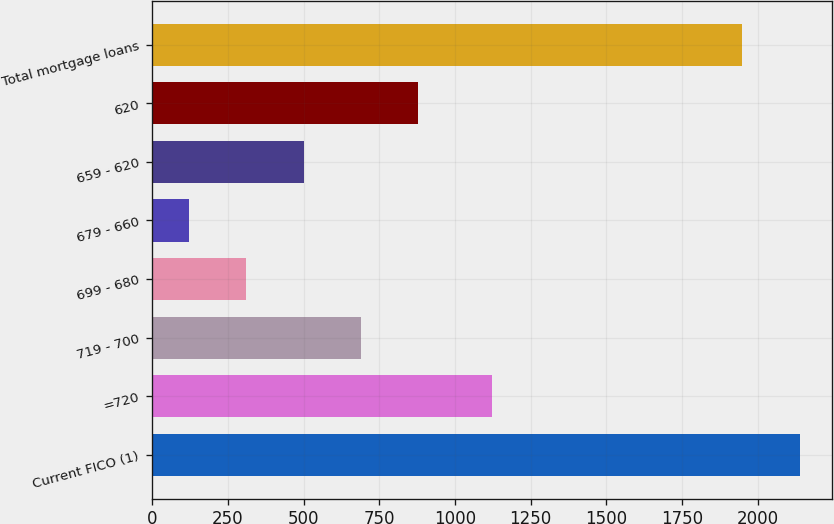Convert chart. <chart><loc_0><loc_0><loc_500><loc_500><bar_chart><fcel>Current FICO (1)<fcel>=720<fcel>719 - 700<fcel>699 - 680<fcel>679 - 660<fcel>659 - 620<fcel>620<fcel>Total mortgage loans<nl><fcel>2139.5<fcel>1121<fcel>689.5<fcel>310.5<fcel>121<fcel>500<fcel>879<fcel>1950<nl></chart> 